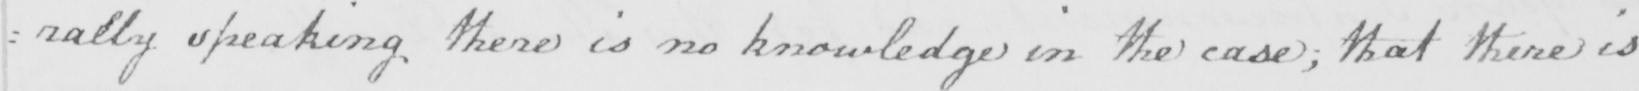Can you read and transcribe this handwriting? : ally speaking there is no knowledge in the case ; that there is 